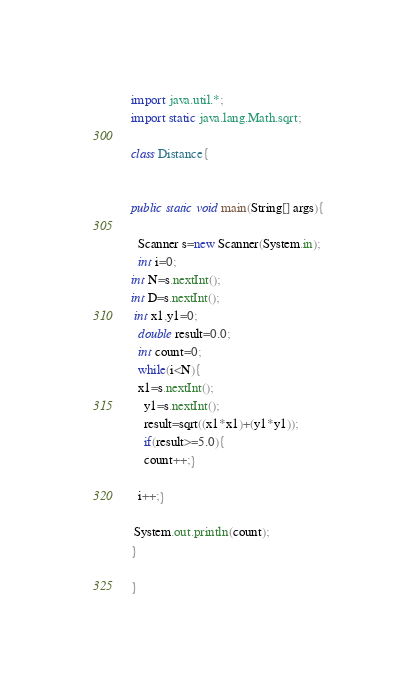Convert code to text. <code><loc_0><loc_0><loc_500><loc_500><_Java_>import java.util.*;
import static java.lang.Math.sqrt;
 
class Distance{
 
 
public static void main(String[] args){
  
  Scanner s=new Scanner(System.in);
  int i=0;
int N=s.nextInt();
int D=s.nextInt();
 int x1,y1=0;
  double result=0.0;
  int count=0;
  while(i<N){
  x1=s.nextInt();
    y1=s.nextInt();
    result=sqrt((x1*x1)+(y1*y1));
    if(result>=5.0){
    count++;}
  
  i++;}
  
 System.out.println(count);
}
 
}</code> 